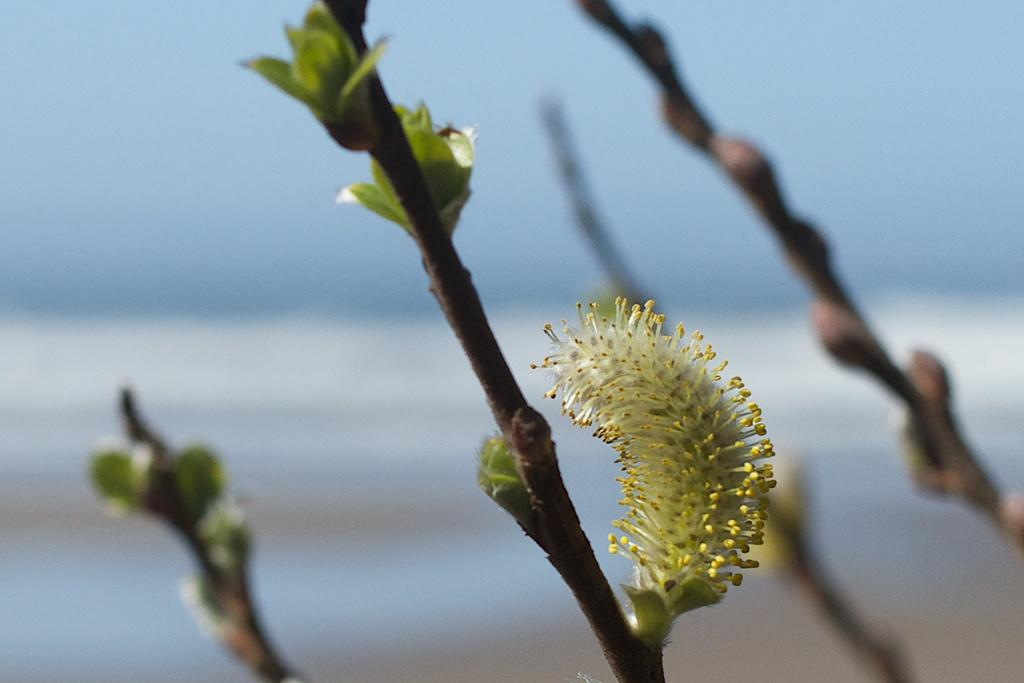What type of living organisms can be seen in the image? Plants and a flower are visible in the image. Can you describe the flower in the image? There is a flower in the image, but its specific characteristics are not clear due to the blurry background. What can be said about the background of the image? The background of the image is blurry. What type of horse can be seen grazing in the background of the image? There is no horse present in the image; it features plants and a flower with a blurry background. What date is marked on the calendar in the image? There is no calendar present in the image. 